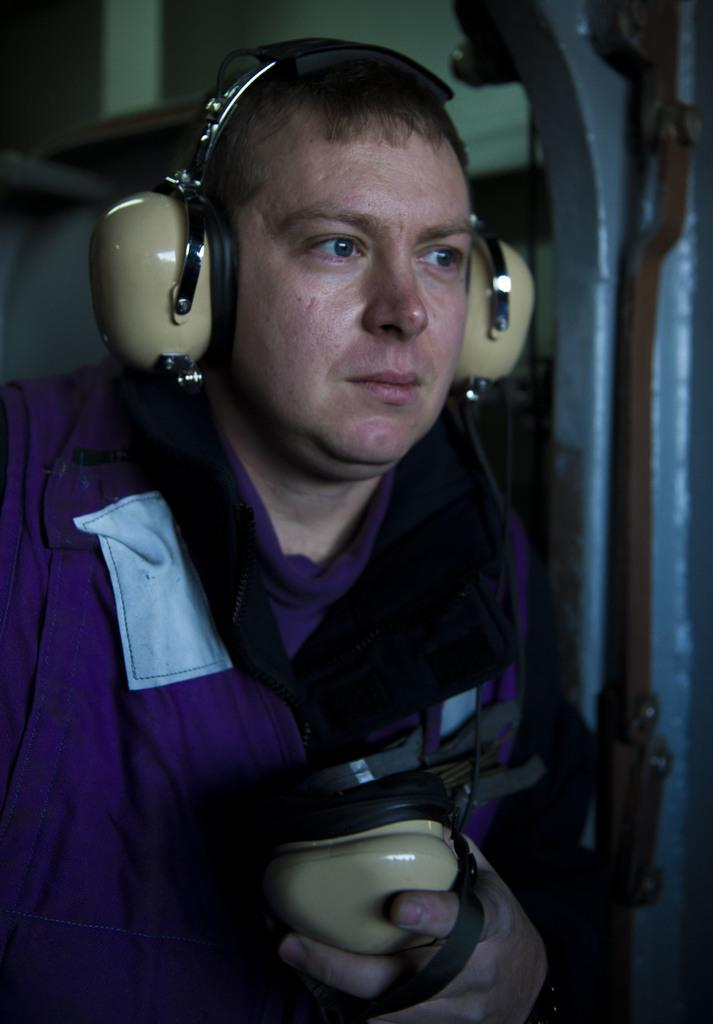What can be seen in the image? There is a person in the image. What is the person wearing? The person is wearing a headset. What is the person holding? The person is holding a headset. What object can be seen on the right side of the image? There is an iron object on the right side of the image. What type of dinosaurs can be seen in the image? There are no dinosaurs present in the image. How does the person express regret in the image? The image does not show any indication of the person expressing regret. 